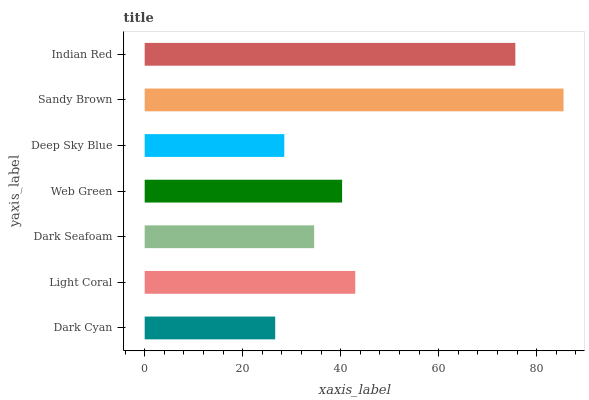Is Dark Cyan the minimum?
Answer yes or no. Yes. Is Sandy Brown the maximum?
Answer yes or no. Yes. Is Light Coral the minimum?
Answer yes or no. No. Is Light Coral the maximum?
Answer yes or no. No. Is Light Coral greater than Dark Cyan?
Answer yes or no. Yes. Is Dark Cyan less than Light Coral?
Answer yes or no. Yes. Is Dark Cyan greater than Light Coral?
Answer yes or no. No. Is Light Coral less than Dark Cyan?
Answer yes or no. No. Is Web Green the high median?
Answer yes or no. Yes. Is Web Green the low median?
Answer yes or no. Yes. Is Indian Red the high median?
Answer yes or no. No. Is Light Coral the low median?
Answer yes or no. No. 